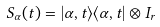Convert formula to latex. <formula><loc_0><loc_0><loc_500><loc_500>S _ { \alpha } ( t ) = | \alpha , t \rangle \langle \alpha , t | \otimes I _ { r }</formula> 